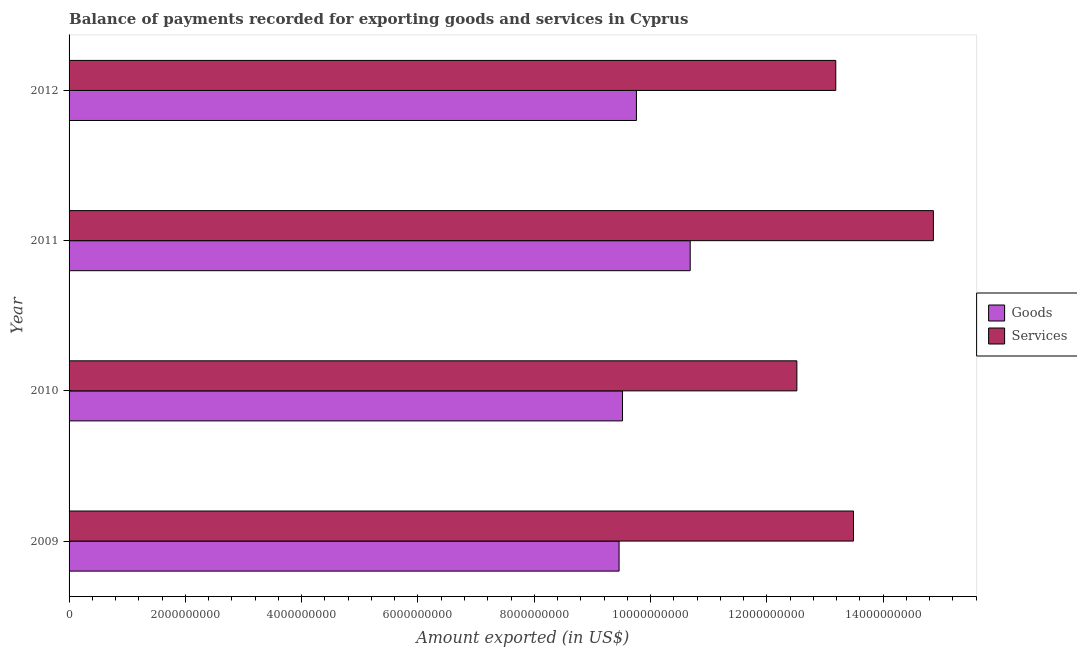How many groups of bars are there?
Your answer should be very brief. 4. Are the number of bars per tick equal to the number of legend labels?
Provide a succinct answer. Yes. How many bars are there on the 3rd tick from the top?
Your response must be concise. 2. What is the label of the 3rd group of bars from the top?
Make the answer very short. 2010. In how many cases, is the number of bars for a given year not equal to the number of legend labels?
Keep it short and to the point. 0. What is the amount of services exported in 2010?
Your answer should be very brief. 1.25e+1. Across all years, what is the maximum amount of goods exported?
Make the answer very short. 1.07e+1. Across all years, what is the minimum amount of goods exported?
Give a very brief answer. 9.46e+09. In which year was the amount of services exported maximum?
Your answer should be compact. 2011. In which year was the amount of services exported minimum?
Provide a short and direct response. 2010. What is the total amount of goods exported in the graph?
Keep it short and to the point. 3.94e+1. What is the difference between the amount of goods exported in 2009 and that in 2010?
Your response must be concise. -5.90e+07. What is the difference between the amount of goods exported in 2011 and the amount of services exported in 2012?
Ensure brevity in your answer.  -2.50e+09. What is the average amount of services exported per year?
Provide a short and direct response. 1.35e+1. In the year 2010, what is the difference between the amount of goods exported and amount of services exported?
Your answer should be very brief. -3.00e+09. What is the ratio of the amount of goods exported in 2011 to that in 2012?
Offer a very short reply. 1.09. Is the amount of services exported in 2009 less than that in 2010?
Offer a terse response. No. What is the difference between the highest and the second highest amount of goods exported?
Offer a terse response. 9.25e+08. What is the difference between the highest and the lowest amount of goods exported?
Provide a succinct answer. 1.22e+09. What does the 1st bar from the top in 2009 represents?
Provide a succinct answer. Services. What does the 1st bar from the bottom in 2011 represents?
Give a very brief answer. Goods. Does the graph contain grids?
Offer a very short reply. No. Where does the legend appear in the graph?
Provide a short and direct response. Center right. What is the title of the graph?
Provide a short and direct response. Balance of payments recorded for exporting goods and services in Cyprus. Does "Secondary school" appear as one of the legend labels in the graph?
Your answer should be very brief. No. What is the label or title of the X-axis?
Ensure brevity in your answer.  Amount exported (in US$). What is the Amount exported (in US$) of Goods in 2009?
Provide a short and direct response. 9.46e+09. What is the Amount exported (in US$) in Services in 2009?
Make the answer very short. 1.35e+1. What is the Amount exported (in US$) in Goods in 2010?
Provide a short and direct response. 9.52e+09. What is the Amount exported (in US$) in Services in 2010?
Make the answer very short. 1.25e+1. What is the Amount exported (in US$) in Goods in 2011?
Provide a short and direct response. 1.07e+1. What is the Amount exported (in US$) in Services in 2011?
Make the answer very short. 1.49e+1. What is the Amount exported (in US$) of Goods in 2012?
Offer a very short reply. 9.76e+09. What is the Amount exported (in US$) of Services in 2012?
Your answer should be very brief. 1.32e+1. Across all years, what is the maximum Amount exported (in US$) in Goods?
Make the answer very short. 1.07e+1. Across all years, what is the maximum Amount exported (in US$) in Services?
Ensure brevity in your answer.  1.49e+1. Across all years, what is the minimum Amount exported (in US$) in Goods?
Give a very brief answer. 9.46e+09. Across all years, what is the minimum Amount exported (in US$) in Services?
Provide a short and direct response. 1.25e+1. What is the total Amount exported (in US$) in Goods in the graph?
Your response must be concise. 3.94e+1. What is the total Amount exported (in US$) in Services in the graph?
Give a very brief answer. 5.41e+1. What is the difference between the Amount exported (in US$) of Goods in 2009 and that in 2010?
Make the answer very short. -5.90e+07. What is the difference between the Amount exported (in US$) in Services in 2009 and that in 2010?
Make the answer very short. 9.74e+08. What is the difference between the Amount exported (in US$) of Goods in 2009 and that in 2011?
Provide a succinct answer. -1.22e+09. What is the difference between the Amount exported (in US$) in Services in 2009 and that in 2011?
Provide a succinct answer. -1.37e+09. What is the difference between the Amount exported (in US$) in Goods in 2009 and that in 2012?
Make the answer very short. -2.98e+08. What is the difference between the Amount exported (in US$) in Services in 2009 and that in 2012?
Provide a short and direct response. 3.05e+08. What is the difference between the Amount exported (in US$) of Goods in 2010 and that in 2011?
Your response must be concise. -1.16e+09. What is the difference between the Amount exported (in US$) in Services in 2010 and that in 2011?
Make the answer very short. -2.35e+09. What is the difference between the Amount exported (in US$) in Goods in 2010 and that in 2012?
Make the answer very short. -2.39e+08. What is the difference between the Amount exported (in US$) of Services in 2010 and that in 2012?
Your answer should be compact. -6.69e+08. What is the difference between the Amount exported (in US$) of Goods in 2011 and that in 2012?
Your response must be concise. 9.25e+08. What is the difference between the Amount exported (in US$) of Services in 2011 and that in 2012?
Offer a terse response. 1.68e+09. What is the difference between the Amount exported (in US$) in Goods in 2009 and the Amount exported (in US$) in Services in 2010?
Ensure brevity in your answer.  -3.06e+09. What is the difference between the Amount exported (in US$) of Goods in 2009 and the Amount exported (in US$) of Services in 2011?
Offer a very short reply. -5.41e+09. What is the difference between the Amount exported (in US$) of Goods in 2009 and the Amount exported (in US$) of Services in 2012?
Make the answer very short. -3.73e+09. What is the difference between the Amount exported (in US$) in Goods in 2010 and the Amount exported (in US$) in Services in 2011?
Your answer should be compact. -5.35e+09. What is the difference between the Amount exported (in US$) in Goods in 2010 and the Amount exported (in US$) in Services in 2012?
Provide a succinct answer. -3.67e+09. What is the difference between the Amount exported (in US$) in Goods in 2011 and the Amount exported (in US$) in Services in 2012?
Give a very brief answer. -2.50e+09. What is the average Amount exported (in US$) in Goods per year?
Keep it short and to the point. 9.85e+09. What is the average Amount exported (in US$) in Services per year?
Make the answer very short. 1.35e+1. In the year 2009, what is the difference between the Amount exported (in US$) of Goods and Amount exported (in US$) of Services?
Provide a succinct answer. -4.03e+09. In the year 2010, what is the difference between the Amount exported (in US$) of Goods and Amount exported (in US$) of Services?
Provide a succinct answer. -3.00e+09. In the year 2011, what is the difference between the Amount exported (in US$) in Goods and Amount exported (in US$) in Services?
Give a very brief answer. -4.18e+09. In the year 2012, what is the difference between the Amount exported (in US$) in Goods and Amount exported (in US$) in Services?
Keep it short and to the point. -3.43e+09. What is the ratio of the Amount exported (in US$) of Services in 2009 to that in 2010?
Your answer should be very brief. 1.08. What is the ratio of the Amount exported (in US$) in Goods in 2009 to that in 2011?
Your response must be concise. 0.89. What is the ratio of the Amount exported (in US$) in Services in 2009 to that in 2011?
Offer a terse response. 0.91. What is the ratio of the Amount exported (in US$) of Goods in 2009 to that in 2012?
Your response must be concise. 0.97. What is the ratio of the Amount exported (in US$) of Services in 2009 to that in 2012?
Your answer should be compact. 1.02. What is the ratio of the Amount exported (in US$) in Goods in 2010 to that in 2011?
Provide a short and direct response. 0.89. What is the ratio of the Amount exported (in US$) of Services in 2010 to that in 2011?
Ensure brevity in your answer.  0.84. What is the ratio of the Amount exported (in US$) in Goods in 2010 to that in 2012?
Your response must be concise. 0.98. What is the ratio of the Amount exported (in US$) of Services in 2010 to that in 2012?
Provide a short and direct response. 0.95. What is the ratio of the Amount exported (in US$) of Goods in 2011 to that in 2012?
Your answer should be compact. 1.09. What is the ratio of the Amount exported (in US$) in Services in 2011 to that in 2012?
Make the answer very short. 1.13. What is the difference between the highest and the second highest Amount exported (in US$) of Goods?
Your answer should be compact. 9.25e+08. What is the difference between the highest and the second highest Amount exported (in US$) in Services?
Your answer should be very brief. 1.37e+09. What is the difference between the highest and the lowest Amount exported (in US$) in Goods?
Make the answer very short. 1.22e+09. What is the difference between the highest and the lowest Amount exported (in US$) in Services?
Your answer should be compact. 2.35e+09. 